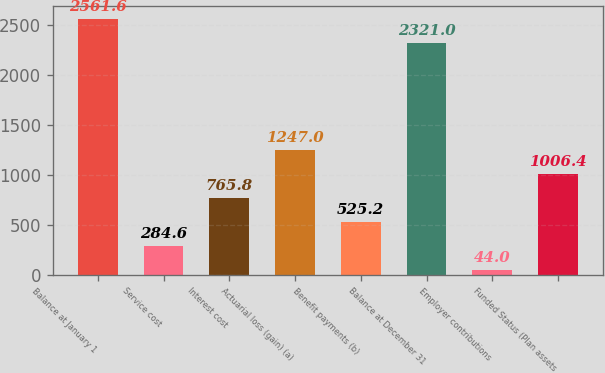Convert chart. <chart><loc_0><loc_0><loc_500><loc_500><bar_chart><fcel>Balance at January 1<fcel>Service cost<fcel>Interest cost<fcel>Actuarial loss (gain) (a)<fcel>Benefit payments (b)<fcel>Balance at December 31<fcel>Employer contributions<fcel>Funded Status (Plan assets<nl><fcel>2561.6<fcel>284.6<fcel>765.8<fcel>1247<fcel>525.2<fcel>2321<fcel>44<fcel>1006.4<nl></chart> 